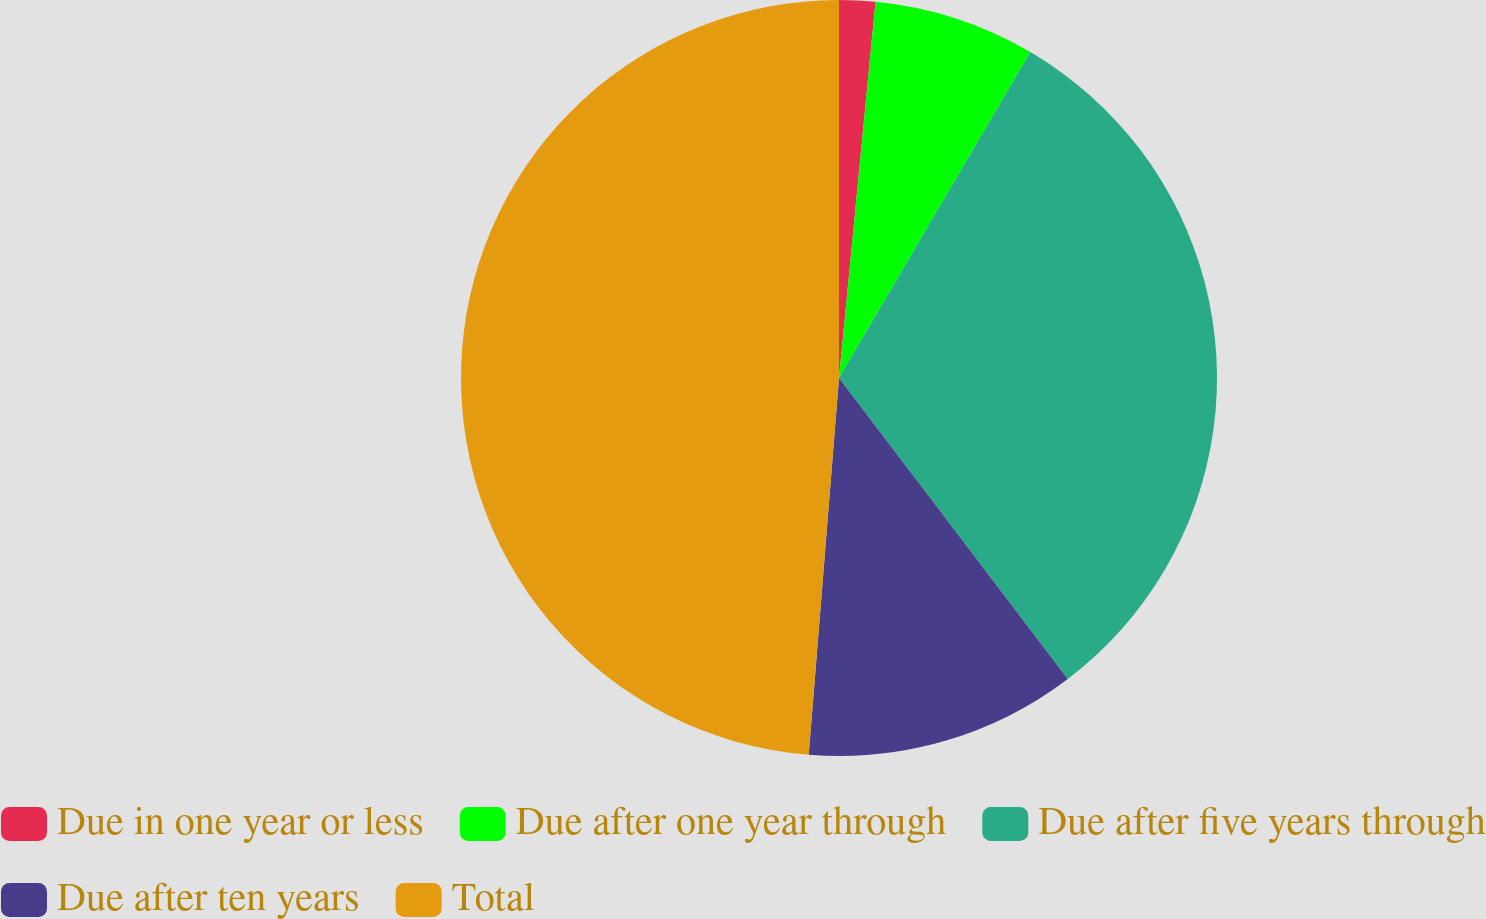Convert chart to OTSL. <chart><loc_0><loc_0><loc_500><loc_500><pie_chart><fcel>Due in one year or less<fcel>Due after one year through<fcel>Due after five years through<fcel>Due after ten years<fcel>Total<nl><fcel>1.54%<fcel>6.91%<fcel>31.2%<fcel>11.62%<fcel>48.72%<nl></chart> 